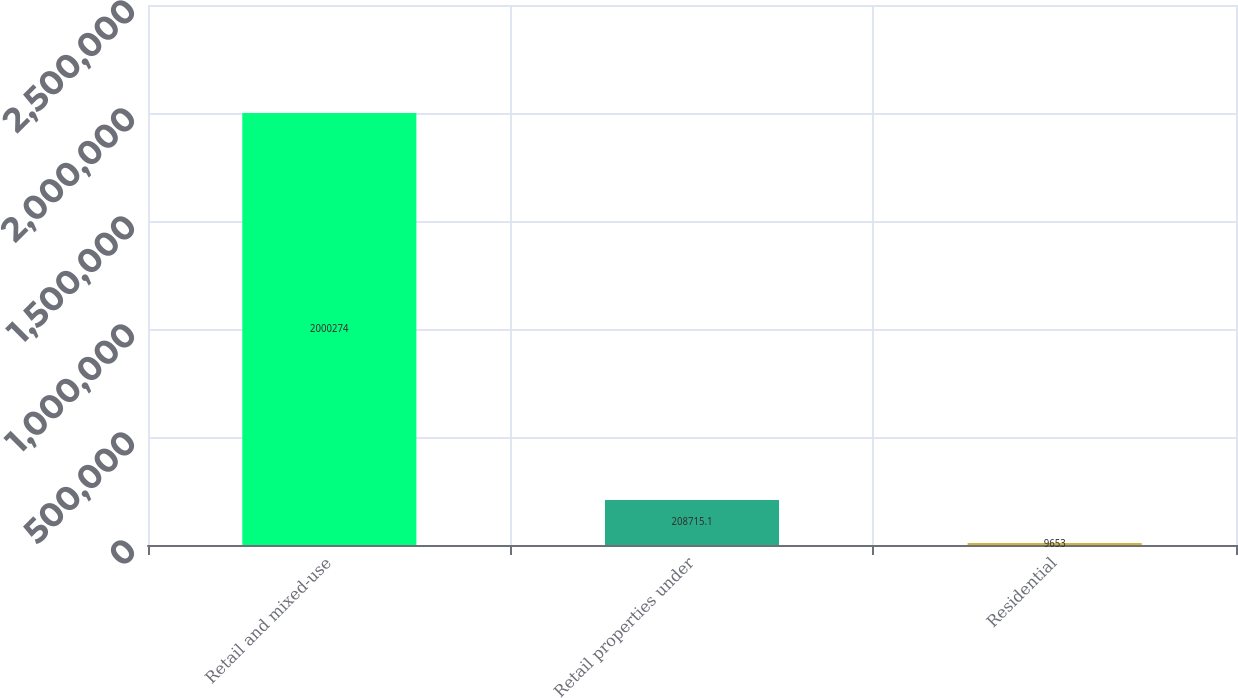Convert chart to OTSL. <chart><loc_0><loc_0><loc_500><loc_500><bar_chart><fcel>Retail and mixed-use<fcel>Retail properties under<fcel>Residential<nl><fcel>2.00027e+06<fcel>208715<fcel>9653<nl></chart> 